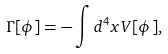<formula> <loc_0><loc_0><loc_500><loc_500>\Gamma [ \phi ] = - \int d ^ { 4 } x V [ \phi ] ,</formula> 